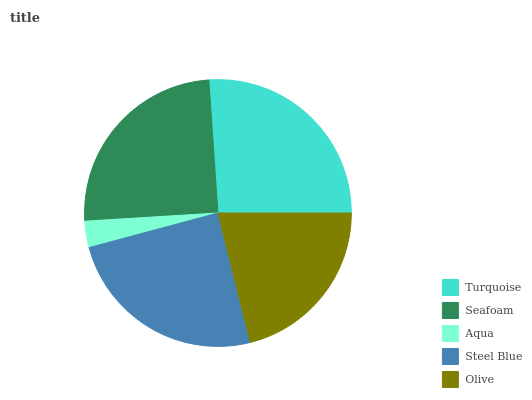Is Aqua the minimum?
Answer yes or no. Yes. Is Turquoise the maximum?
Answer yes or no. Yes. Is Seafoam the minimum?
Answer yes or no. No. Is Seafoam the maximum?
Answer yes or no. No. Is Turquoise greater than Seafoam?
Answer yes or no. Yes. Is Seafoam less than Turquoise?
Answer yes or no. Yes. Is Seafoam greater than Turquoise?
Answer yes or no. No. Is Turquoise less than Seafoam?
Answer yes or no. No. Is Steel Blue the high median?
Answer yes or no. Yes. Is Steel Blue the low median?
Answer yes or no. Yes. Is Turquoise the high median?
Answer yes or no. No. Is Aqua the low median?
Answer yes or no. No. 